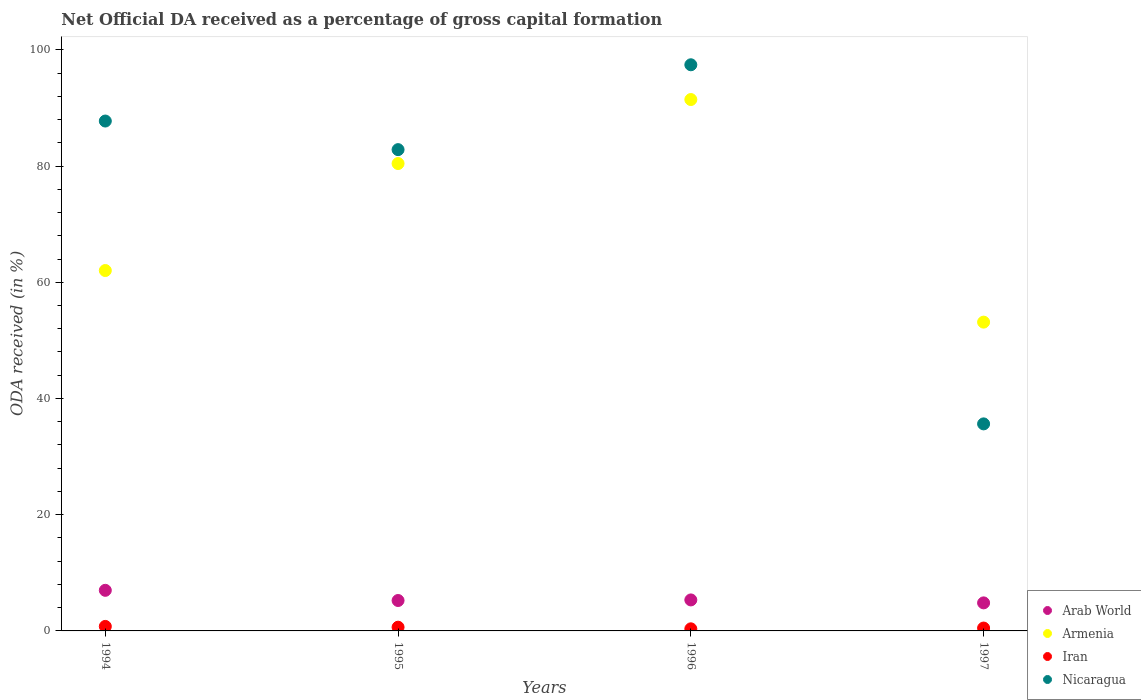How many different coloured dotlines are there?
Your response must be concise. 4. What is the net ODA received in Arab World in 1995?
Offer a terse response. 5.23. Across all years, what is the maximum net ODA received in Iran?
Ensure brevity in your answer.  0.77. Across all years, what is the minimum net ODA received in Iran?
Your answer should be compact. 0.36. What is the total net ODA received in Iran in the graph?
Give a very brief answer. 2.27. What is the difference between the net ODA received in Iran in 1994 and that in 1996?
Provide a succinct answer. 0.41. What is the difference between the net ODA received in Arab World in 1997 and the net ODA received in Nicaragua in 1996?
Keep it short and to the point. -92.6. What is the average net ODA received in Arab World per year?
Provide a succinct answer. 5.6. In the year 1997, what is the difference between the net ODA received in Arab World and net ODA received in Nicaragua?
Provide a succinct answer. -30.8. In how many years, is the net ODA received in Nicaragua greater than 76 %?
Give a very brief answer. 3. What is the ratio of the net ODA received in Armenia in 1994 to that in 1997?
Your answer should be very brief. 1.17. Is the net ODA received in Iran in 1994 less than that in 1997?
Your answer should be compact. No. Is the difference between the net ODA received in Arab World in 1996 and 1997 greater than the difference between the net ODA received in Nicaragua in 1996 and 1997?
Offer a terse response. No. What is the difference between the highest and the second highest net ODA received in Armenia?
Give a very brief answer. 11.01. What is the difference between the highest and the lowest net ODA received in Armenia?
Your answer should be very brief. 38.31. In how many years, is the net ODA received in Armenia greater than the average net ODA received in Armenia taken over all years?
Offer a terse response. 2. Is the sum of the net ODA received in Armenia in 1995 and 1997 greater than the maximum net ODA received in Nicaragua across all years?
Provide a succinct answer. Yes. Is the net ODA received in Arab World strictly less than the net ODA received in Nicaragua over the years?
Provide a short and direct response. Yes. How many dotlines are there?
Your answer should be compact. 4. Are the values on the major ticks of Y-axis written in scientific E-notation?
Keep it short and to the point. No. Does the graph contain grids?
Provide a short and direct response. No. How many legend labels are there?
Offer a very short reply. 4. How are the legend labels stacked?
Keep it short and to the point. Vertical. What is the title of the graph?
Your answer should be compact. Net Official DA received as a percentage of gross capital formation. What is the label or title of the Y-axis?
Your answer should be very brief. ODA received (in %). What is the ODA received (in %) of Arab World in 1994?
Keep it short and to the point. 6.99. What is the ODA received (in %) in Armenia in 1994?
Provide a succinct answer. 62.02. What is the ODA received (in %) in Iran in 1994?
Give a very brief answer. 0.77. What is the ODA received (in %) in Nicaragua in 1994?
Provide a short and direct response. 87.74. What is the ODA received (in %) of Arab World in 1995?
Give a very brief answer. 5.23. What is the ODA received (in %) of Armenia in 1995?
Your answer should be compact. 80.43. What is the ODA received (in %) in Iran in 1995?
Give a very brief answer. 0.64. What is the ODA received (in %) in Nicaragua in 1995?
Keep it short and to the point. 82.82. What is the ODA received (in %) in Arab World in 1996?
Give a very brief answer. 5.33. What is the ODA received (in %) of Armenia in 1996?
Your answer should be very brief. 91.44. What is the ODA received (in %) of Iran in 1996?
Keep it short and to the point. 0.36. What is the ODA received (in %) of Nicaragua in 1996?
Keep it short and to the point. 97.43. What is the ODA received (in %) in Arab World in 1997?
Your response must be concise. 4.83. What is the ODA received (in %) of Armenia in 1997?
Offer a very short reply. 53.14. What is the ODA received (in %) of Iran in 1997?
Make the answer very short. 0.49. What is the ODA received (in %) in Nicaragua in 1997?
Provide a short and direct response. 35.63. Across all years, what is the maximum ODA received (in %) of Arab World?
Provide a short and direct response. 6.99. Across all years, what is the maximum ODA received (in %) in Armenia?
Keep it short and to the point. 91.44. Across all years, what is the maximum ODA received (in %) of Iran?
Make the answer very short. 0.77. Across all years, what is the maximum ODA received (in %) of Nicaragua?
Your response must be concise. 97.43. Across all years, what is the minimum ODA received (in %) of Arab World?
Offer a terse response. 4.83. Across all years, what is the minimum ODA received (in %) of Armenia?
Ensure brevity in your answer.  53.14. Across all years, what is the minimum ODA received (in %) of Iran?
Provide a succinct answer. 0.36. Across all years, what is the minimum ODA received (in %) of Nicaragua?
Provide a succinct answer. 35.63. What is the total ODA received (in %) in Arab World in the graph?
Provide a short and direct response. 22.38. What is the total ODA received (in %) in Armenia in the graph?
Provide a succinct answer. 287.03. What is the total ODA received (in %) in Iran in the graph?
Your answer should be very brief. 2.27. What is the total ODA received (in %) of Nicaragua in the graph?
Keep it short and to the point. 303.62. What is the difference between the ODA received (in %) in Arab World in 1994 and that in 1995?
Your answer should be compact. 1.75. What is the difference between the ODA received (in %) of Armenia in 1994 and that in 1995?
Keep it short and to the point. -18.41. What is the difference between the ODA received (in %) in Iran in 1994 and that in 1995?
Offer a terse response. 0.13. What is the difference between the ODA received (in %) in Nicaragua in 1994 and that in 1995?
Offer a very short reply. 4.92. What is the difference between the ODA received (in %) in Arab World in 1994 and that in 1996?
Your response must be concise. 1.65. What is the difference between the ODA received (in %) of Armenia in 1994 and that in 1996?
Your response must be concise. -29.43. What is the difference between the ODA received (in %) of Iran in 1994 and that in 1996?
Give a very brief answer. 0.41. What is the difference between the ODA received (in %) of Nicaragua in 1994 and that in 1996?
Your answer should be compact. -9.68. What is the difference between the ODA received (in %) of Arab World in 1994 and that in 1997?
Your answer should be very brief. 2.16. What is the difference between the ODA received (in %) of Armenia in 1994 and that in 1997?
Ensure brevity in your answer.  8.88. What is the difference between the ODA received (in %) of Iran in 1994 and that in 1997?
Keep it short and to the point. 0.28. What is the difference between the ODA received (in %) in Nicaragua in 1994 and that in 1997?
Keep it short and to the point. 52.12. What is the difference between the ODA received (in %) of Arab World in 1995 and that in 1996?
Provide a succinct answer. -0.1. What is the difference between the ODA received (in %) of Armenia in 1995 and that in 1996?
Ensure brevity in your answer.  -11.01. What is the difference between the ODA received (in %) in Iran in 1995 and that in 1996?
Provide a succinct answer. 0.28. What is the difference between the ODA received (in %) of Nicaragua in 1995 and that in 1996?
Keep it short and to the point. -14.6. What is the difference between the ODA received (in %) in Arab World in 1995 and that in 1997?
Offer a terse response. 0.41. What is the difference between the ODA received (in %) in Armenia in 1995 and that in 1997?
Make the answer very short. 27.29. What is the difference between the ODA received (in %) of Iran in 1995 and that in 1997?
Your answer should be compact. 0.15. What is the difference between the ODA received (in %) of Nicaragua in 1995 and that in 1997?
Provide a short and direct response. 47.19. What is the difference between the ODA received (in %) in Arab World in 1996 and that in 1997?
Ensure brevity in your answer.  0.51. What is the difference between the ODA received (in %) of Armenia in 1996 and that in 1997?
Your answer should be very brief. 38.31. What is the difference between the ODA received (in %) in Iran in 1996 and that in 1997?
Give a very brief answer. -0.13. What is the difference between the ODA received (in %) of Nicaragua in 1996 and that in 1997?
Your answer should be very brief. 61.8. What is the difference between the ODA received (in %) in Arab World in 1994 and the ODA received (in %) in Armenia in 1995?
Your answer should be compact. -73.44. What is the difference between the ODA received (in %) in Arab World in 1994 and the ODA received (in %) in Iran in 1995?
Ensure brevity in your answer.  6.35. What is the difference between the ODA received (in %) in Arab World in 1994 and the ODA received (in %) in Nicaragua in 1995?
Your answer should be compact. -75.84. What is the difference between the ODA received (in %) of Armenia in 1994 and the ODA received (in %) of Iran in 1995?
Keep it short and to the point. 61.38. What is the difference between the ODA received (in %) of Armenia in 1994 and the ODA received (in %) of Nicaragua in 1995?
Your response must be concise. -20.8. What is the difference between the ODA received (in %) in Iran in 1994 and the ODA received (in %) in Nicaragua in 1995?
Offer a very short reply. -82.05. What is the difference between the ODA received (in %) of Arab World in 1994 and the ODA received (in %) of Armenia in 1996?
Keep it short and to the point. -84.46. What is the difference between the ODA received (in %) in Arab World in 1994 and the ODA received (in %) in Iran in 1996?
Keep it short and to the point. 6.63. What is the difference between the ODA received (in %) of Arab World in 1994 and the ODA received (in %) of Nicaragua in 1996?
Ensure brevity in your answer.  -90.44. What is the difference between the ODA received (in %) of Armenia in 1994 and the ODA received (in %) of Iran in 1996?
Keep it short and to the point. 61.66. What is the difference between the ODA received (in %) in Armenia in 1994 and the ODA received (in %) in Nicaragua in 1996?
Ensure brevity in your answer.  -35.41. What is the difference between the ODA received (in %) in Iran in 1994 and the ODA received (in %) in Nicaragua in 1996?
Ensure brevity in your answer.  -96.65. What is the difference between the ODA received (in %) in Arab World in 1994 and the ODA received (in %) in Armenia in 1997?
Provide a short and direct response. -46.15. What is the difference between the ODA received (in %) in Arab World in 1994 and the ODA received (in %) in Iran in 1997?
Ensure brevity in your answer.  6.49. What is the difference between the ODA received (in %) of Arab World in 1994 and the ODA received (in %) of Nicaragua in 1997?
Make the answer very short. -28.64. What is the difference between the ODA received (in %) in Armenia in 1994 and the ODA received (in %) in Iran in 1997?
Offer a very short reply. 61.52. What is the difference between the ODA received (in %) in Armenia in 1994 and the ODA received (in %) in Nicaragua in 1997?
Keep it short and to the point. 26.39. What is the difference between the ODA received (in %) of Iran in 1994 and the ODA received (in %) of Nicaragua in 1997?
Your response must be concise. -34.85. What is the difference between the ODA received (in %) in Arab World in 1995 and the ODA received (in %) in Armenia in 1996?
Provide a short and direct response. -86.21. What is the difference between the ODA received (in %) of Arab World in 1995 and the ODA received (in %) of Iran in 1996?
Offer a terse response. 4.87. What is the difference between the ODA received (in %) of Arab World in 1995 and the ODA received (in %) of Nicaragua in 1996?
Provide a short and direct response. -92.19. What is the difference between the ODA received (in %) of Armenia in 1995 and the ODA received (in %) of Iran in 1996?
Provide a succinct answer. 80.07. What is the difference between the ODA received (in %) of Armenia in 1995 and the ODA received (in %) of Nicaragua in 1996?
Offer a very short reply. -16.99. What is the difference between the ODA received (in %) of Iran in 1995 and the ODA received (in %) of Nicaragua in 1996?
Your answer should be very brief. -96.78. What is the difference between the ODA received (in %) in Arab World in 1995 and the ODA received (in %) in Armenia in 1997?
Keep it short and to the point. -47.91. What is the difference between the ODA received (in %) of Arab World in 1995 and the ODA received (in %) of Iran in 1997?
Your response must be concise. 4.74. What is the difference between the ODA received (in %) in Arab World in 1995 and the ODA received (in %) in Nicaragua in 1997?
Provide a short and direct response. -30.39. What is the difference between the ODA received (in %) in Armenia in 1995 and the ODA received (in %) in Iran in 1997?
Keep it short and to the point. 79.94. What is the difference between the ODA received (in %) in Armenia in 1995 and the ODA received (in %) in Nicaragua in 1997?
Offer a very short reply. 44.8. What is the difference between the ODA received (in %) of Iran in 1995 and the ODA received (in %) of Nicaragua in 1997?
Keep it short and to the point. -34.99. What is the difference between the ODA received (in %) of Arab World in 1996 and the ODA received (in %) of Armenia in 1997?
Provide a short and direct response. -47.8. What is the difference between the ODA received (in %) of Arab World in 1996 and the ODA received (in %) of Iran in 1997?
Provide a succinct answer. 4.84. What is the difference between the ODA received (in %) in Arab World in 1996 and the ODA received (in %) in Nicaragua in 1997?
Ensure brevity in your answer.  -30.29. What is the difference between the ODA received (in %) of Armenia in 1996 and the ODA received (in %) of Iran in 1997?
Your response must be concise. 90.95. What is the difference between the ODA received (in %) of Armenia in 1996 and the ODA received (in %) of Nicaragua in 1997?
Make the answer very short. 55.82. What is the difference between the ODA received (in %) in Iran in 1996 and the ODA received (in %) in Nicaragua in 1997?
Provide a short and direct response. -35.27. What is the average ODA received (in %) in Arab World per year?
Your answer should be very brief. 5.6. What is the average ODA received (in %) in Armenia per year?
Provide a short and direct response. 71.76. What is the average ODA received (in %) of Iran per year?
Provide a short and direct response. 0.57. What is the average ODA received (in %) in Nicaragua per year?
Your answer should be very brief. 75.91. In the year 1994, what is the difference between the ODA received (in %) in Arab World and ODA received (in %) in Armenia?
Keep it short and to the point. -55.03. In the year 1994, what is the difference between the ODA received (in %) in Arab World and ODA received (in %) in Iran?
Provide a succinct answer. 6.21. In the year 1994, what is the difference between the ODA received (in %) of Arab World and ODA received (in %) of Nicaragua?
Offer a very short reply. -80.76. In the year 1994, what is the difference between the ODA received (in %) of Armenia and ODA received (in %) of Iran?
Offer a very short reply. 61.24. In the year 1994, what is the difference between the ODA received (in %) of Armenia and ODA received (in %) of Nicaragua?
Your answer should be very brief. -25.73. In the year 1994, what is the difference between the ODA received (in %) of Iran and ODA received (in %) of Nicaragua?
Your answer should be very brief. -86.97. In the year 1995, what is the difference between the ODA received (in %) of Arab World and ODA received (in %) of Armenia?
Offer a terse response. -75.2. In the year 1995, what is the difference between the ODA received (in %) of Arab World and ODA received (in %) of Iran?
Provide a succinct answer. 4.59. In the year 1995, what is the difference between the ODA received (in %) of Arab World and ODA received (in %) of Nicaragua?
Your answer should be compact. -77.59. In the year 1995, what is the difference between the ODA received (in %) in Armenia and ODA received (in %) in Iran?
Make the answer very short. 79.79. In the year 1995, what is the difference between the ODA received (in %) in Armenia and ODA received (in %) in Nicaragua?
Keep it short and to the point. -2.39. In the year 1995, what is the difference between the ODA received (in %) of Iran and ODA received (in %) of Nicaragua?
Give a very brief answer. -82.18. In the year 1996, what is the difference between the ODA received (in %) in Arab World and ODA received (in %) in Armenia?
Offer a terse response. -86.11. In the year 1996, what is the difference between the ODA received (in %) in Arab World and ODA received (in %) in Iran?
Keep it short and to the point. 4.97. In the year 1996, what is the difference between the ODA received (in %) in Arab World and ODA received (in %) in Nicaragua?
Your answer should be very brief. -92.09. In the year 1996, what is the difference between the ODA received (in %) in Armenia and ODA received (in %) in Iran?
Ensure brevity in your answer.  91.08. In the year 1996, what is the difference between the ODA received (in %) of Armenia and ODA received (in %) of Nicaragua?
Give a very brief answer. -5.98. In the year 1996, what is the difference between the ODA received (in %) in Iran and ODA received (in %) in Nicaragua?
Your response must be concise. -97.07. In the year 1997, what is the difference between the ODA received (in %) of Arab World and ODA received (in %) of Armenia?
Provide a short and direct response. -48.31. In the year 1997, what is the difference between the ODA received (in %) in Arab World and ODA received (in %) in Iran?
Offer a terse response. 4.33. In the year 1997, what is the difference between the ODA received (in %) in Arab World and ODA received (in %) in Nicaragua?
Provide a short and direct response. -30.8. In the year 1997, what is the difference between the ODA received (in %) in Armenia and ODA received (in %) in Iran?
Keep it short and to the point. 52.64. In the year 1997, what is the difference between the ODA received (in %) of Armenia and ODA received (in %) of Nicaragua?
Your answer should be compact. 17.51. In the year 1997, what is the difference between the ODA received (in %) in Iran and ODA received (in %) in Nicaragua?
Give a very brief answer. -35.13. What is the ratio of the ODA received (in %) of Arab World in 1994 to that in 1995?
Your response must be concise. 1.34. What is the ratio of the ODA received (in %) in Armenia in 1994 to that in 1995?
Keep it short and to the point. 0.77. What is the ratio of the ODA received (in %) of Iran in 1994 to that in 1995?
Your response must be concise. 1.21. What is the ratio of the ODA received (in %) of Nicaragua in 1994 to that in 1995?
Ensure brevity in your answer.  1.06. What is the ratio of the ODA received (in %) of Arab World in 1994 to that in 1996?
Make the answer very short. 1.31. What is the ratio of the ODA received (in %) of Armenia in 1994 to that in 1996?
Make the answer very short. 0.68. What is the ratio of the ODA received (in %) of Iran in 1994 to that in 1996?
Ensure brevity in your answer.  2.15. What is the ratio of the ODA received (in %) in Nicaragua in 1994 to that in 1996?
Make the answer very short. 0.9. What is the ratio of the ODA received (in %) in Arab World in 1994 to that in 1997?
Make the answer very short. 1.45. What is the ratio of the ODA received (in %) of Armenia in 1994 to that in 1997?
Keep it short and to the point. 1.17. What is the ratio of the ODA received (in %) of Iran in 1994 to that in 1997?
Offer a terse response. 1.57. What is the ratio of the ODA received (in %) in Nicaragua in 1994 to that in 1997?
Your response must be concise. 2.46. What is the ratio of the ODA received (in %) in Arab World in 1995 to that in 1996?
Ensure brevity in your answer.  0.98. What is the ratio of the ODA received (in %) of Armenia in 1995 to that in 1996?
Provide a short and direct response. 0.88. What is the ratio of the ODA received (in %) of Iran in 1995 to that in 1996?
Your answer should be very brief. 1.78. What is the ratio of the ODA received (in %) in Nicaragua in 1995 to that in 1996?
Give a very brief answer. 0.85. What is the ratio of the ODA received (in %) in Arab World in 1995 to that in 1997?
Provide a short and direct response. 1.08. What is the ratio of the ODA received (in %) of Armenia in 1995 to that in 1997?
Offer a very short reply. 1.51. What is the ratio of the ODA received (in %) in Iran in 1995 to that in 1997?
Make the answer very short. 1.3. What is the ratio of the ODA received (in %) in Nicaragua in 1995 to that in 1997?
Your answer should be very brief. 2.32. What is the ratio of the ODA received (in %) in Arab World in 1996 to that in 1997?
Your response must be concise. 1.11. What is the ratio of the ODA received (in %) of Armenia in 1996 to that in 1997?
Keep it short and to the point. 1.72. What is the ratio of the ODA received (in %) in Iran in 1996 to that in 1997?
Offer a very short reply. 0.73. What is the ratio of the ODA received (in %) in Nicaragua in 1996 to that in 1997?
Ensure brevity in your answer.  2.73. What is the difference between the highest and the second highest ODA received (in %) in Arab World?
Your answer should be very brief. 1.65. What is the difference between the highest and the second highest ODA received (in %) in Armenia?
Make the answer very short. 11.01. What is the difference between the highest and the second highest ODA received (in %) of Iran?
Ensure brevity in your answer.  0.13. What is the difference between the highest and the second highest ODA received (in %) of Nicaragua?
Offer a terse response. 9.68. What is the difference between the highest and the lowest ODA received (in %) of Arab World?
Give a very brief answer. 2.16. What is the difference between the highest and the lowest ODA received (in %) in Armenia?
Your response must be concise. 38.31. What is the difference between the highest and the lowest ODA received (in %) of Iran?
Give a very brief answer. 0.41. What is the difference between the highest and the lowest ODA received (in %) in Nicaragua?
Provide a short and direct response. 61.8. 